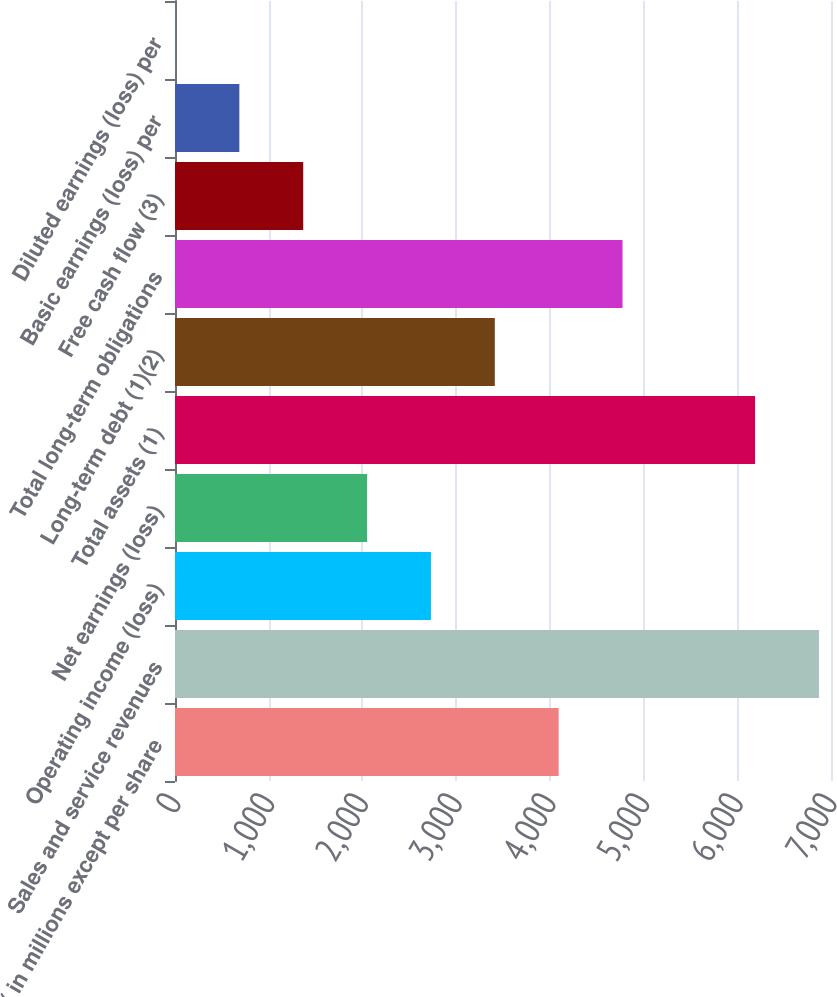<chart> <loc_0><loc_0><loc_500><loc_500><bar_chart><fcel>( in millions except per share<fcel>Sales and service revenues<fcel>Operating income (loss)<fcel>Net earnings (loss)<fcel>Total assets (1)<fcel>Long-term debt (1)(2)<fcel>Total long-term obligations<fcel>Free cash flow (3)<fcel>Basic earnings (loss) per<fcel>Diluted earnings (loss) per<nl><fcel>4094.06<fcel>6871.48<fcel>2731.1<fcel>2049.62<fcel>6190<fcel>3412.58<fcel>4775.54<fcel>1368.14<fcel>686.66<fcel>5.18<nl></chart> 